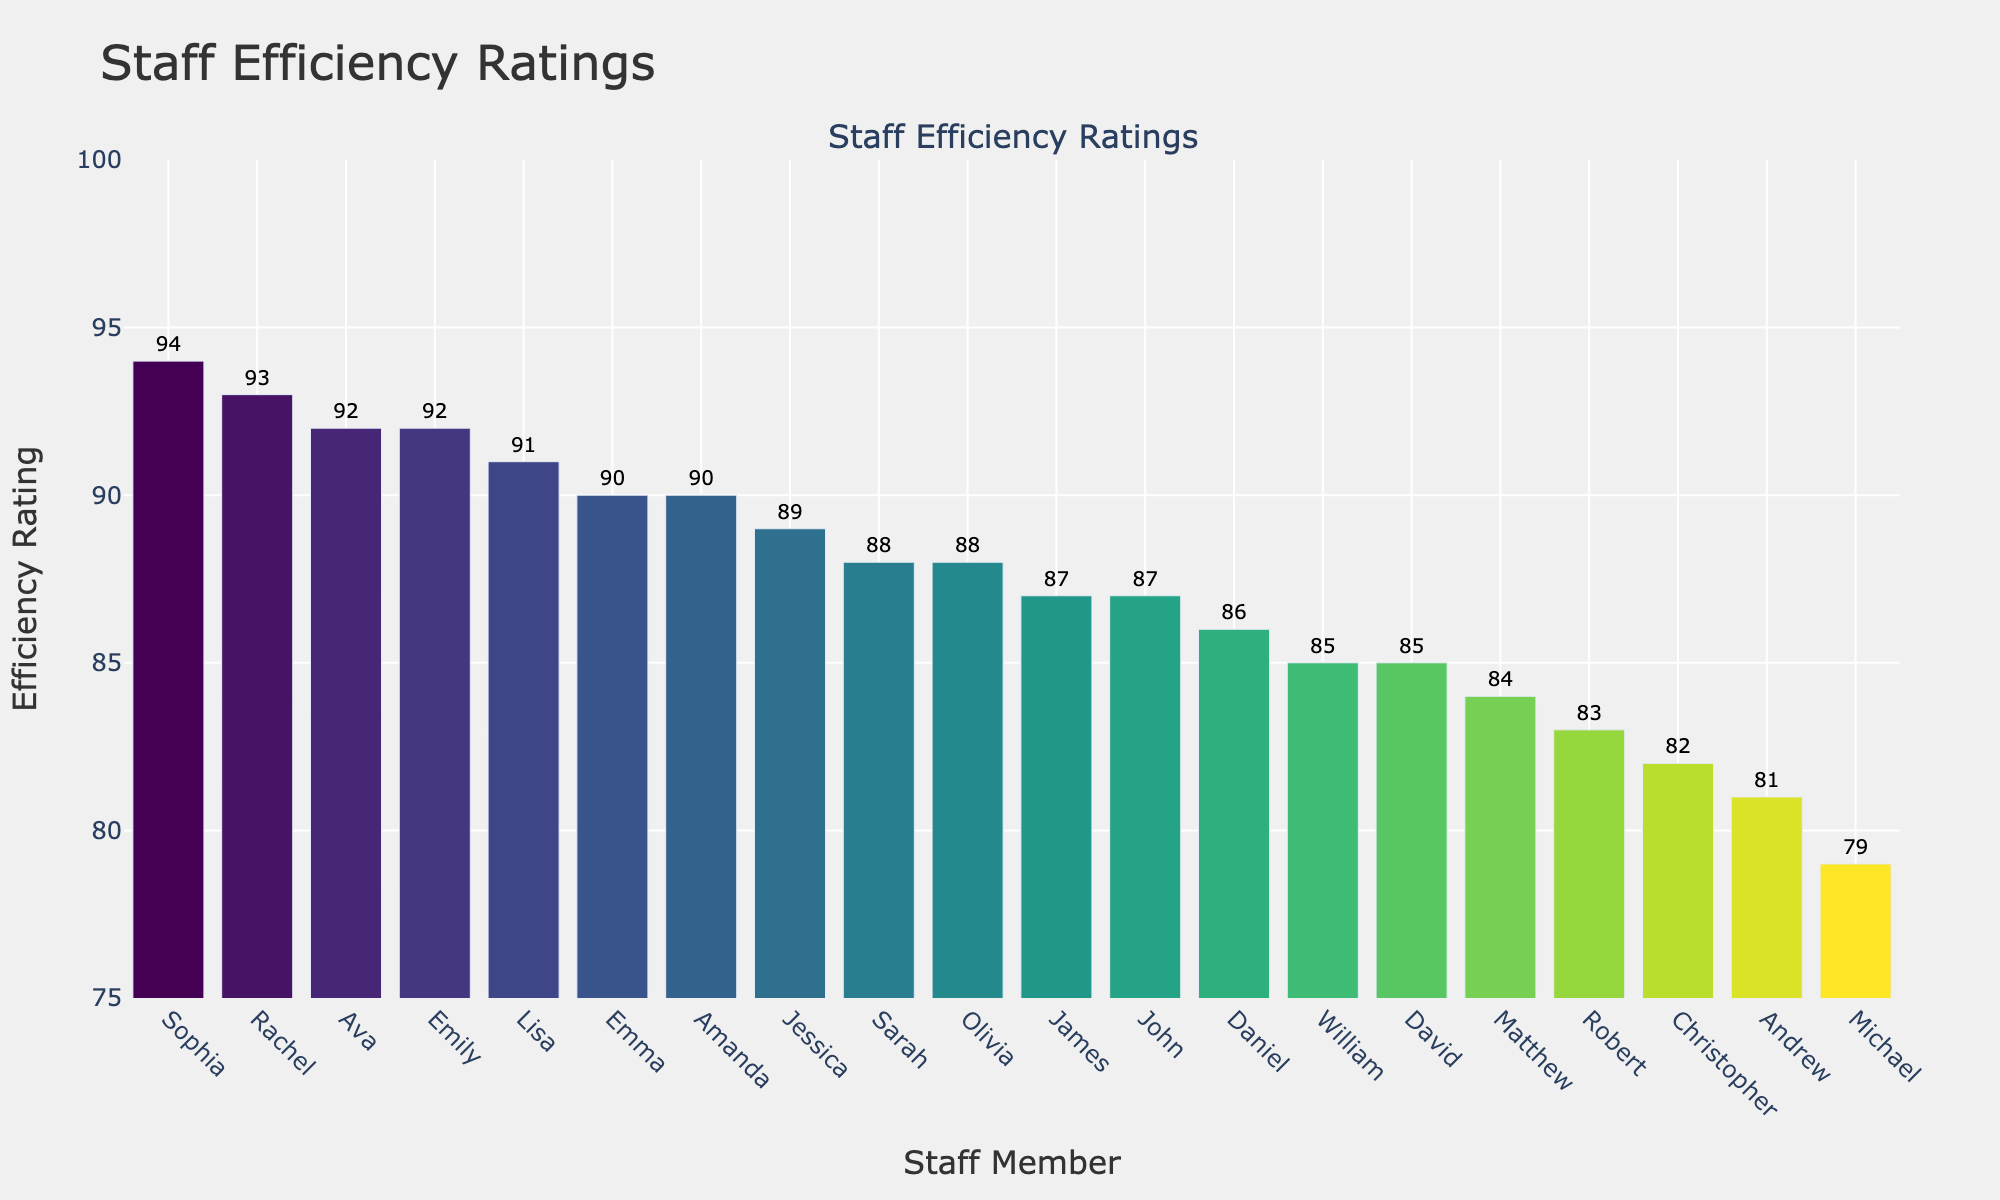Which staff member has the highest efficiency rating? The staff member with the tallest bar represents the highest efficiency rating. The tallest bar corresponds to Sophia.
Answer: Sophia How many staff members have an efficiency rating above 90? Count the number of bars that extend above the 90 mark on the y-axis. There are five bars above the 90 mark.
Answer: 5 Which staff member has a lower efficiency rating: Michael or Amanda? Compare the heights of the bars for Michael and Amanda. Michael's bar is lower than Amanda's.
Answer: Michael What is the difference in efficiency rating between Rachel and John? Find the efficiency ratings of Rachel (93) and John (87) and subtract the smaller from the larger. 93 - 87 = 6
Answer: 6 Is there any staff member with an efficiency rating of exactly 85? Check if any of the bars have a value of 85. Both David and William have this rating.
Answer: Yes What is the average efficiency rating of all staff members? Sum all the efficiency ratings and divide by the number of staff members. The sum is 1754 and the number of staff members is 20, so the average is 1754/20 = 87.7
Answer: 87.7 Are there more staff members with an efficiency rating above 85 or below 85? Count the number of bars above and below the 85 mark on the y-axis. There are 11 staff members above 85 and 9 below.
Answer: Above Which staff member has the third highest efficiency rating? Identify the three tallest bars and find the staff member corresponding to the third one. The third tallest bar is for Emily.
Answer: Emily What is the combined efficiency rating of the staff members with the three lowest ratings? Identify the three shortest bars corresponding to Michael (79), Andrew (81), and Robert (83) and sum their ratings. 79 + 81 + 83 = 243
Answer: 243 Who has a higher efficiency rating: Jessica or Olivia? Compare the heights of the bars for Jessica and Olivia. Both bars have the same height representing the same efficiency rating of 88.
Answer: They are equal 